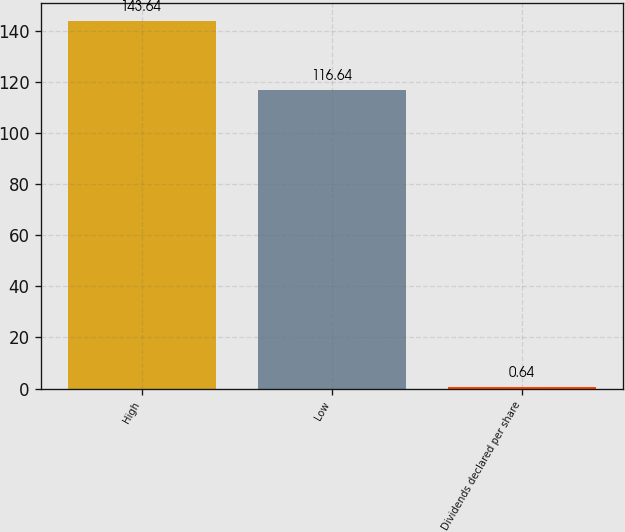<chart> <loc_0><loc_0><loc_500><loc_500><bar_chart><fcel>High<fcel>Low<fcel>Dividends declared per share<nl><fcel>143.64<fcel>116.64<fcel>0.64<nl></chart> 